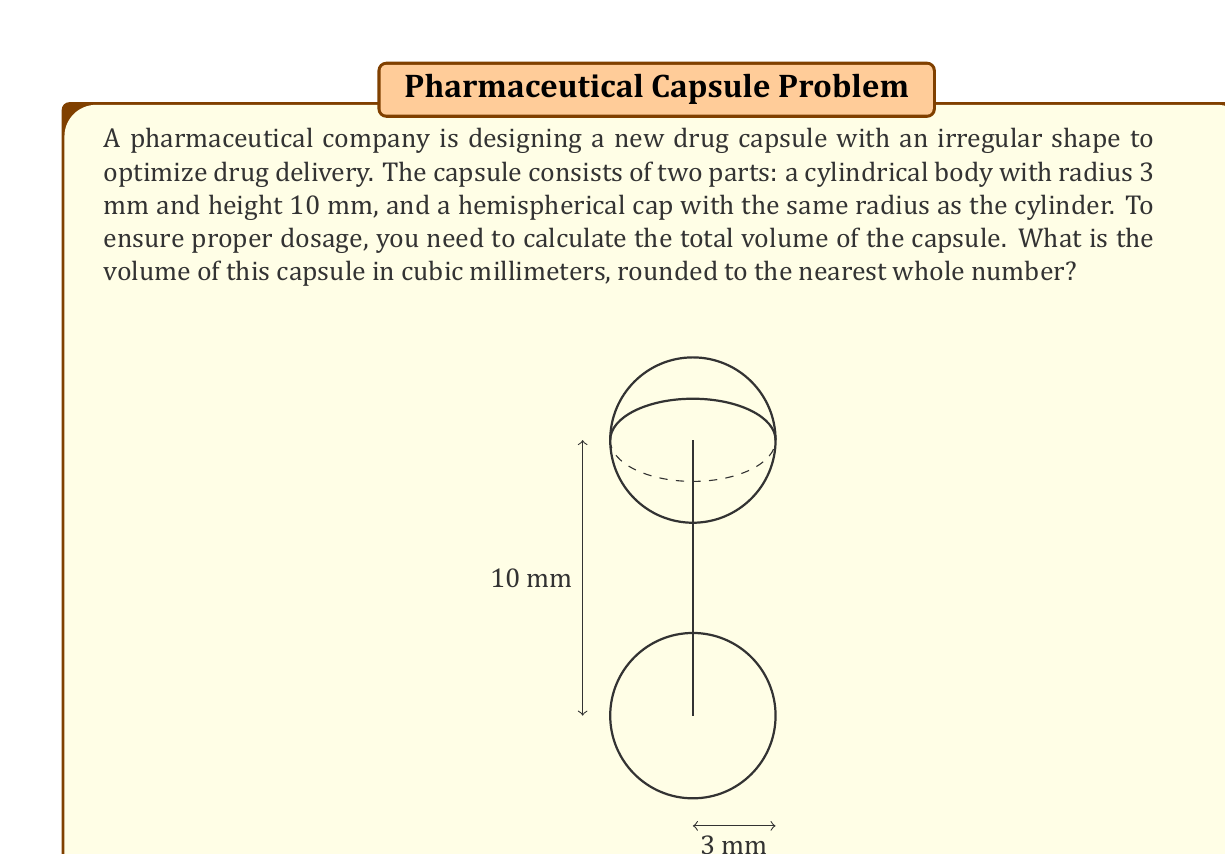What is the answer to this math problem? To calculate the total volume of the capsule, we need to add the volumes of the cylindrical body and the hemispherical cap.

1. Volume of the cylindrical body:
   $$V_{cylinder} = \pi r^2 h$$
   where $r$ is the radius and $h$ is the height.
   $$V_{cylinder} = \pi \cdot 3^2 \cdot 10 = 90\pi \text{ mm}^3$$

2. Volume of the hemispherical cap:
   $$V_{hemisphere} = \frac{2}{3}\pi r^3$$
   $$V_{hemisphere} = \frac{2}{3}\pi \cdot 3^3 = 18\pi \text{ mm}^3$$

3. Total volume:
   $$V_{total} = V_{cylinder} + V_{hemisphere}$$
   $$V_{total} = 90\pi + 18\pi = 108\pi \text{ mm}^3$$

4. Evaluating and rounding to the nearest whole number:
   $$V_{total} = 108\pi \approx 339.29 \text{ mm}^3 \approx 339 \text{ mm}^3$$
Answer: 339 mm³ 